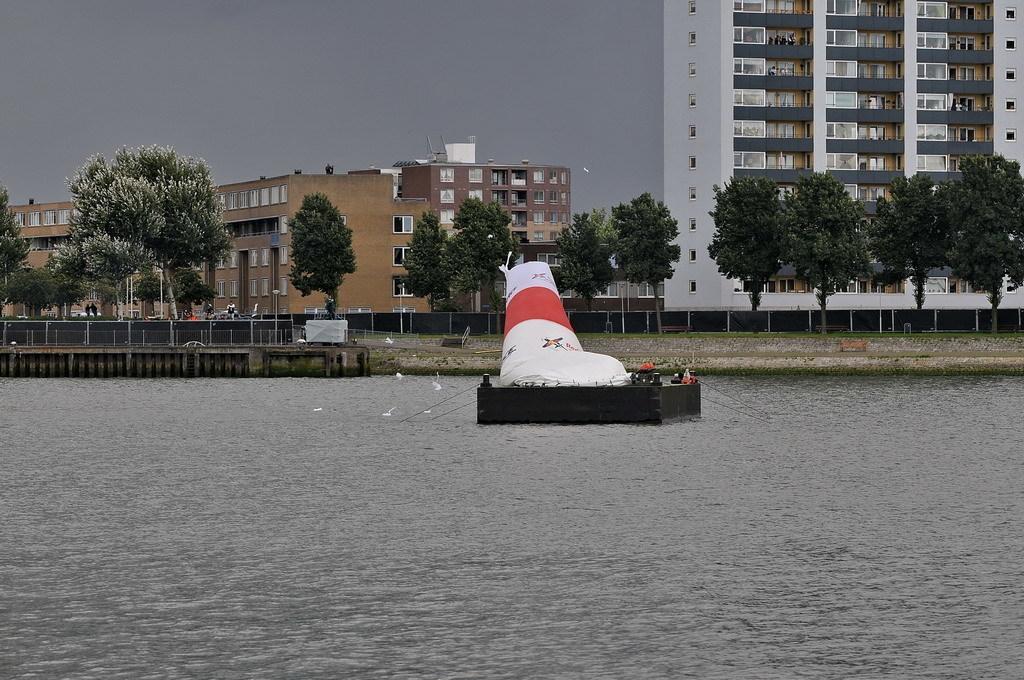Could you give a brief overview of what you see in this image? In the center of the image we can see a boat on the water and there are birds. On the left there is a fence. In the background there are trees, buildings and sky. 